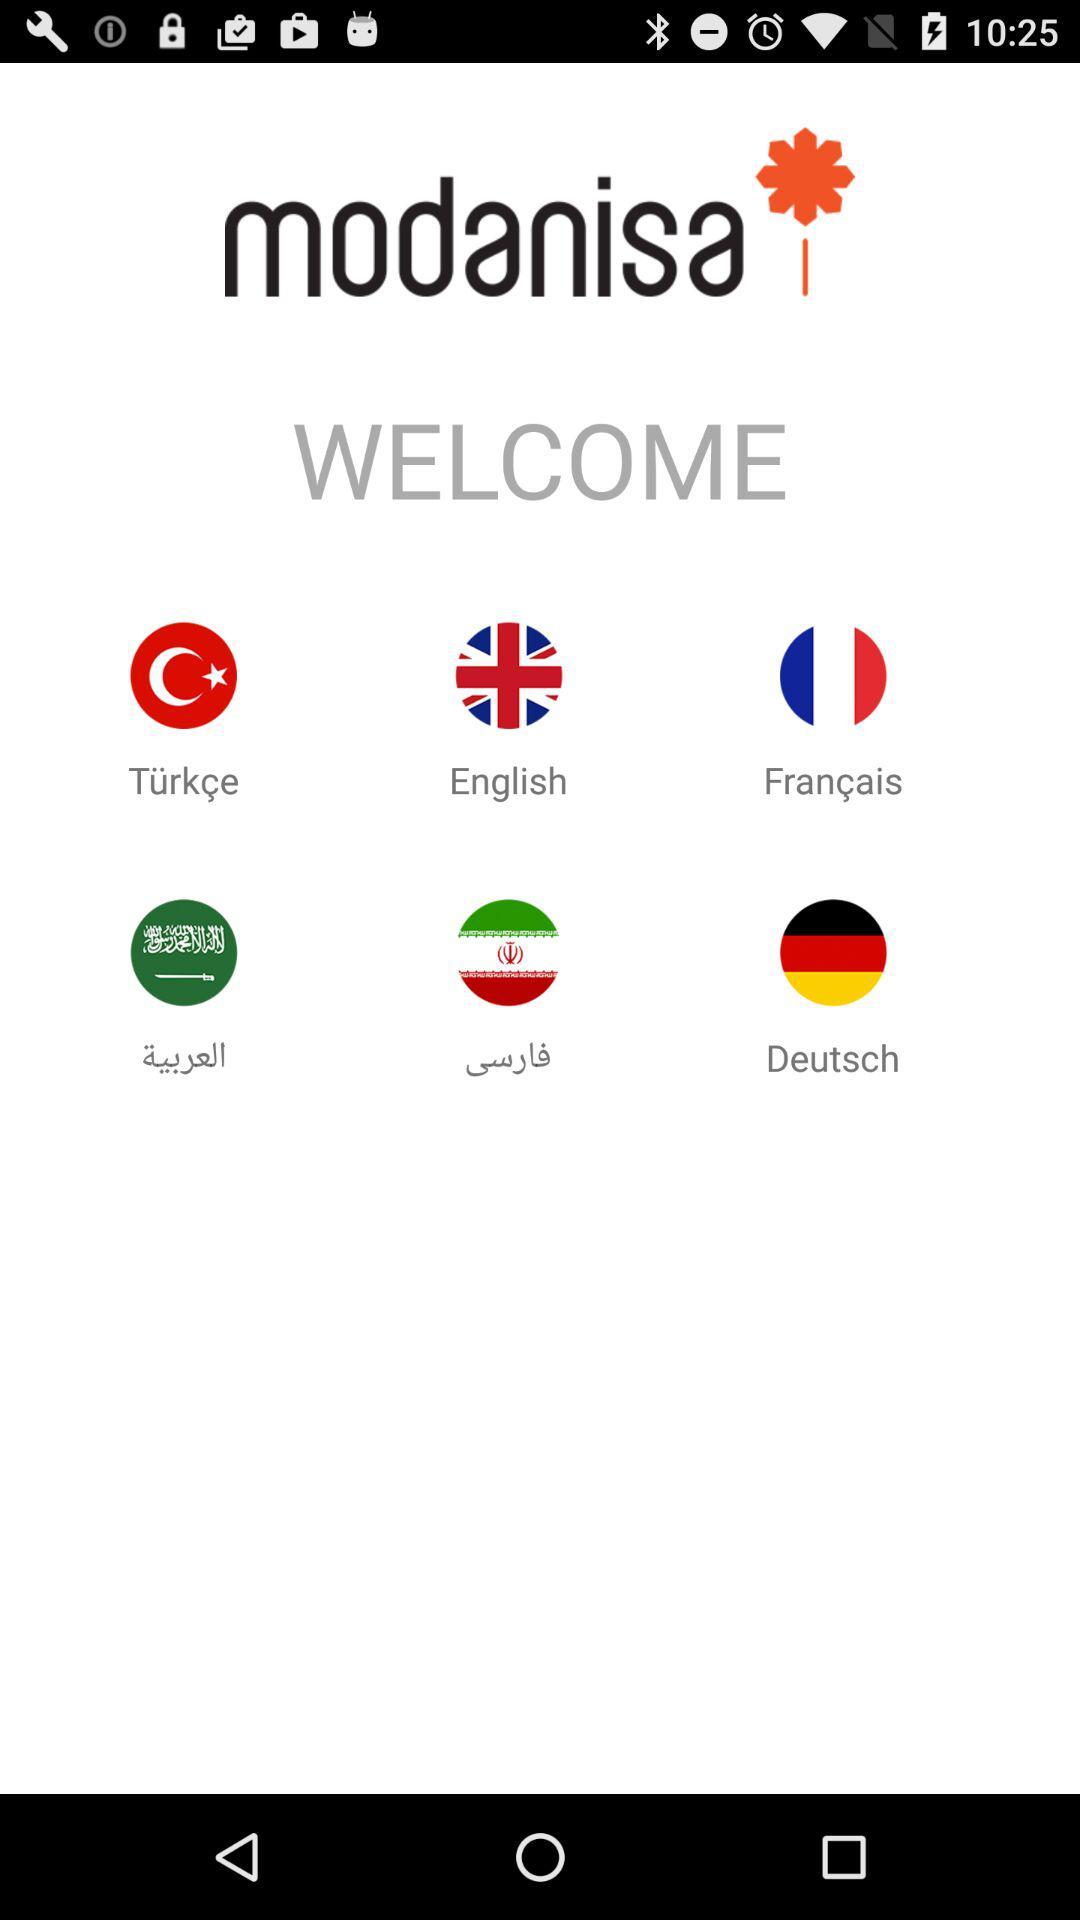What is the application name? The application name is "modanisa". 